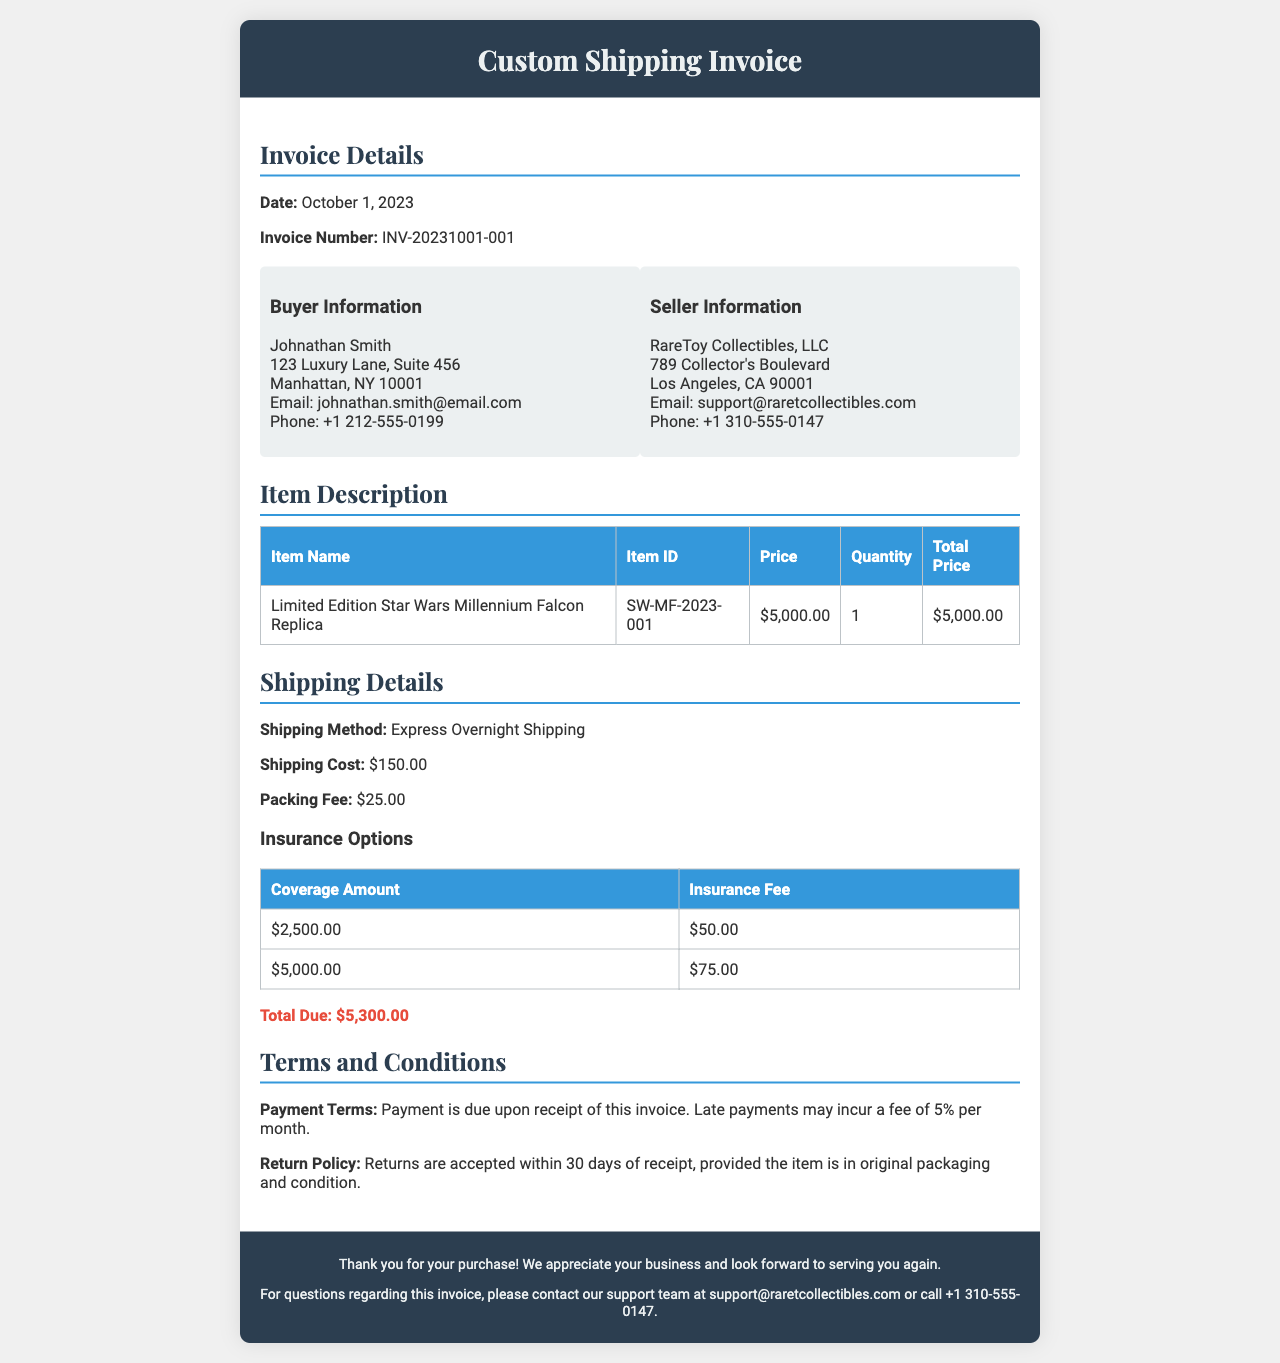What is the invoice number? The invoice number is explicitly stated in the document under the Invoice Details section.
Answer: INV-20231001-001 What is the shipping cost? The shipping cost is listed in the Shipping Details section of the invoice.
Answer: $150.00 Who is the buyer? The buyer's information is provided in the Buyer Information section of the document.
Answer: Johnathan Smith What is the total due amount? The total due is calculated and mentioned at the end of the Shipping Details section.
Answer: $5,300.00 What is the packing fee? The packing fee is detailed in the Shipping Details section of the invoice.
Answer: $25.00 What is the return policy period? The return policy is outlined in the Terms and Conditions section, specifying the return period.
Answer: 30 days What is the coverage amount for the highest insurance fee? The insurance options table provides various coverage amounts with their corresponding fees, highlighting the maximum coverage.
Answer: $5,000.00 What is the payment term for this invoice? The payment terms are stated in the Terms and Conditions section of the document.
Answer: Payment is due upon receipt What is the seller's name? The seller's name and details are included in the Seller Information section of the invoice.
Answer: RareToy Collectibles, LLC 